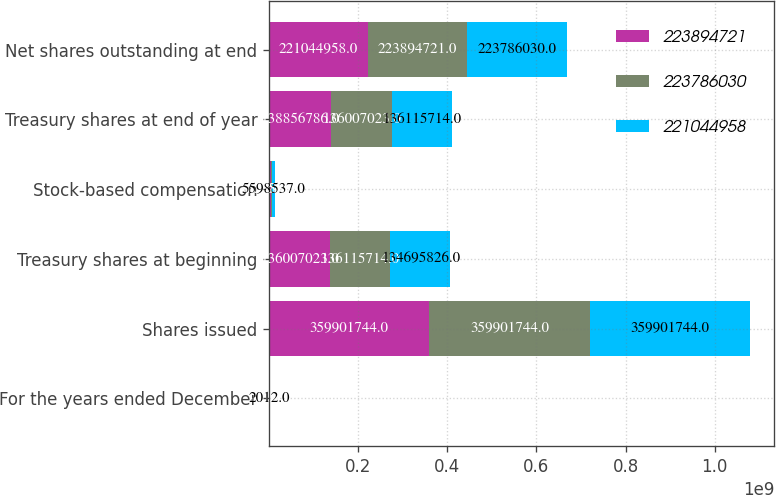Convert chart to OTSL. <chart><loc_0><loc_0><loc_500><loc_500><stacked_bar_chart><ecel><fcel>For the years ended December<fcel>Shares issued<fcel>Treasury shares at beginning<fcel>Stock-based compensation<fcel>Treasury shares at end of year<fcel>Net shares outstanding at end<nl><fcel>2.23895e+08<fcel>2014<fcel>3.59902e+08<fcel>1.36007e+08<fcel>3.67651e+06<fcel>1.38857e+08<fcel>2.21045e+08<nl><fcel>2.23786e+08<fcel>2013<fcel>3.59902e+08<fcel>1.36116e+08<fcel>3.65583e+06<fcel>1.36007e+08<fcel>2.23895e+08<nl><fcel>2.21045e+08<fcel>2012<fcel>3.59902e+08<fcel>1.34696e+08<fcel>5.59854e+06<fcel>1.36116e+08<fcel>2.23786e+08<nl></chart> 